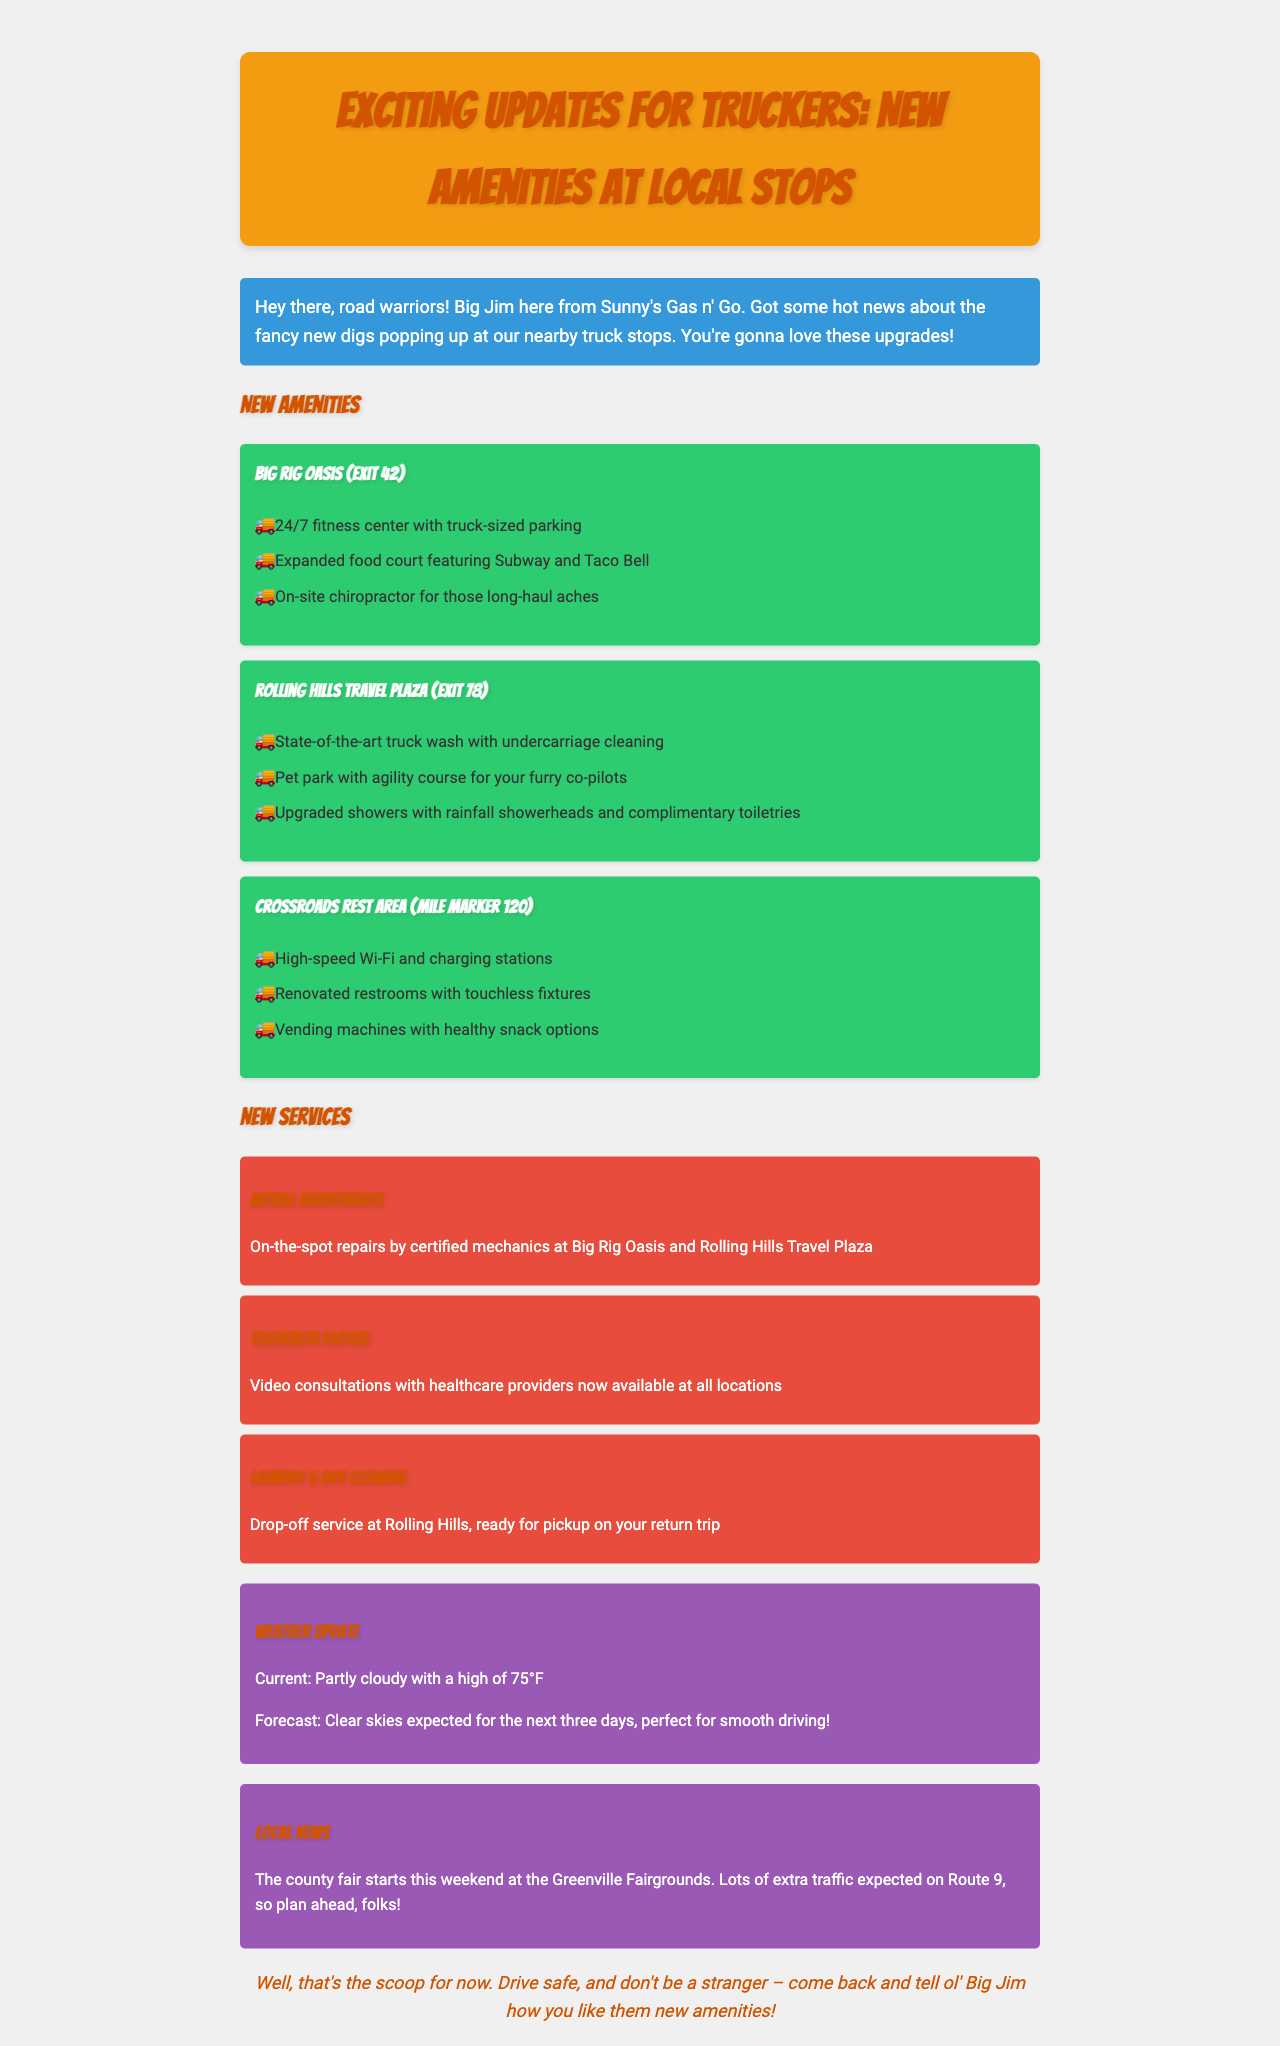What are the new amenities at Big Rig Oasis? The amenities listed for Big Rig Oasis include a 24/7 fitness center, expanded food court, and on-site chiropractor.
Answer: Fitness center, food court, chiropractor What is the current weather condition? The document states the current conditions as "Partly cloudy with a high of 75°F".
Answer: Partly cloudy with a high of 75°F What number exit is Rolling Hills Travel Plaza located at? The information in the document specifies that Rolling Hills Travel Plaza is at Exit 78.
Answer: Exit 78 What new service involves video consultations? The new service that includes video consultations is described as "Telehealth Kiosks".
Answer: Telehealth Kiosks Which truck stop features a pet park? The pet park is mentioned as a feature of Rolling Hills Travel Plaza.
Answer: Rolling Hills Travel Plaza How many days of clear skies are expected? The forecast indicates that clear skies are expected for the next three days.
Answer: Three days What features are included in the upgraded showers at Rolling Hills Travel Plaza? The document states the upgraded showers feature rainfall showerheads and complimentary toiletries.
Answer: Rainfall showerheads, complimentary toiletries What local event is starting this weekend? The local event mentioned is the county fair at the Greenville Fairgrounds.
Answer: County fair What can be repaired on-the-spot according to the new services? The new services allow for on-the-spot repairs by certified mechanics.
Answer: On-the-spot repairs 